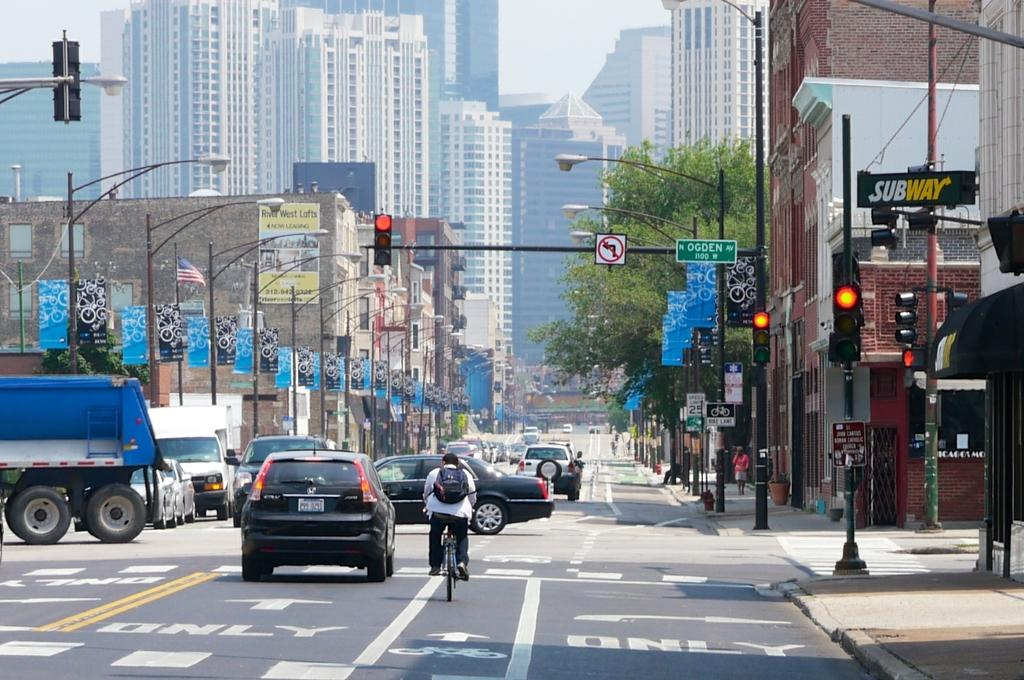What types of vehicles can be seen in the image? There are vehicles in the image, but the specific types are not mentioned. What is the person on the road doing? A person is riding a bicycle on the road. What type of lighting is present along the road? There are street lights in the image. How are the vehicles regulated on the road? There are traffic lights in the image to regulate the vehicles. What structures are visible in the image? There are buildings in the image. What type of vegetation is present in the image? There are trees in the image. What part of the natural environment is visible in the image? The sky is visible in the background of the image. How many bones are visible in the image? There are no bones present in the image. What type of toy can be seen in the hands of the person riding the bicycle? There is no toy visible in the image; the person is riding a bicycle. 